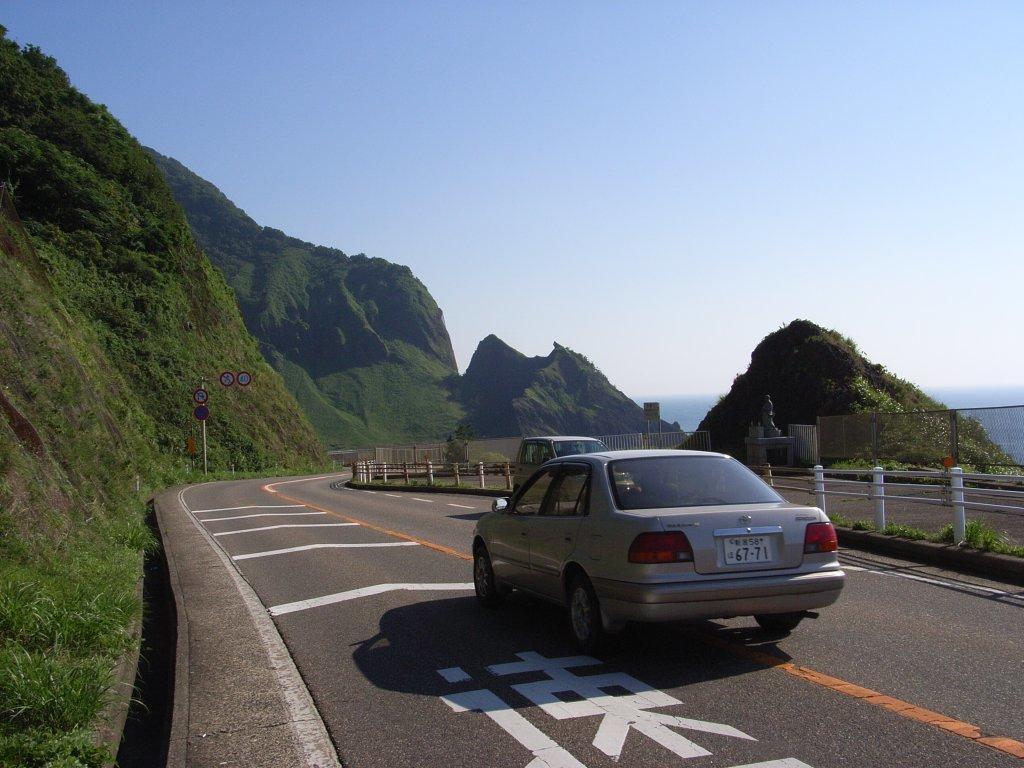How would you summarize this image in a sentence or two? We can see cars on the road and we can see fence and grass. In the background we can see board on poles,hills and sky. 